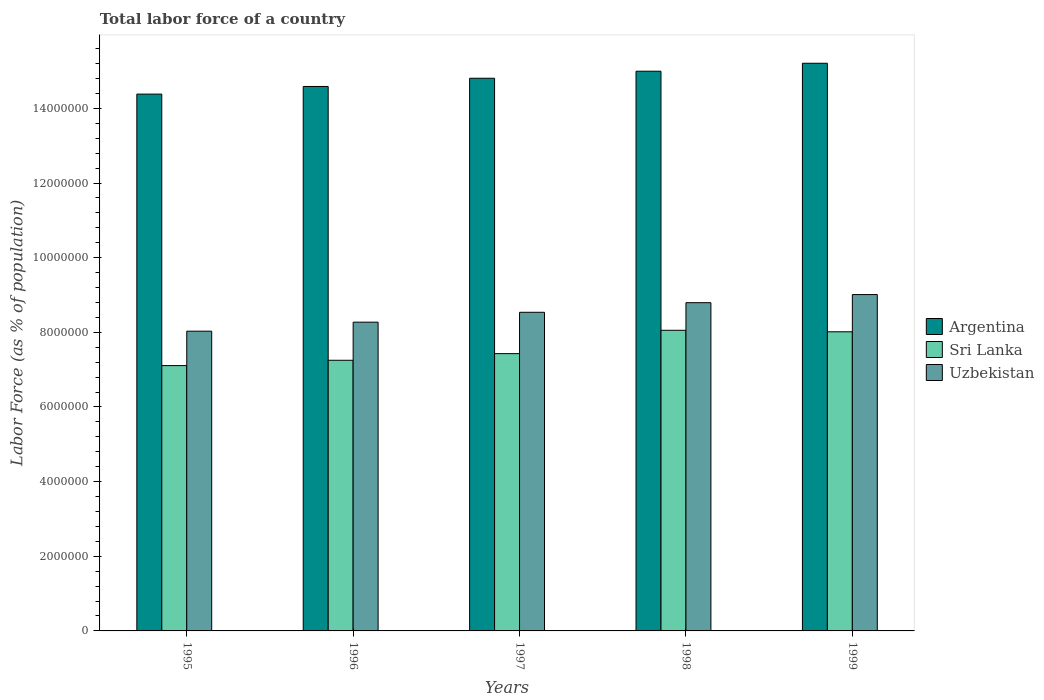Are the number of bars per tick equal to the number of legend labels?
Provide a short and direct response. Yes. Are the number of bars on each tick of the X-axis equal?
Ensure brevity in your answer.  Yes. How many bars are there on the 4th tick from the left?
Give a very brief answer. 3. How many bars are there on the 4th tick from the right?
Offer a very short reply. 3. What is the percentage of labor force in Sri Lanka in 1998?
Your answer should be compact. 8.06e+06. Across all years, what is the maximum percentage of labor force in Uzbekistan?
Give a very brief answer. 9.01e+06. Across all years, what is the minimum percentage of labor force in Argentina?
Your answer should be compact. 1.44e+07. What is the total percentage of labor force in Argentina in the graph?
Your answer should be very brief. 7.40e+07. What is the difference between the percentage of labor force in Argentina in 1996 and that in 1999?
Give a very brief answer. -6.22e+05. What is the difference between the percentage of labor force in Argentina in 1997 and the percentage of labor force in Sri Lanka in 1996?
Your answer should be very brief. 7.56e+06. What is the average percentage of labor force in Argentina per year?
Offer a very short reply. 1.48e+07. In the year 1996, what is the difference between the percentage of labor force in Argentina and percentage of labor force in Sri Lanka?
Ensure brevity in your answer.  7.34e+06. What is the ratio of the percentage of labor force in Uzbekistan in 1997 to that in 1999?
Make the answer very short. 0.95. Is the percentage of labor force in Uzbekistan in 1995 less than that in 1999?
Provide a short and direct response. Yes. What is the difference between the highest and the second highest percentage of labor force in Uzbekistan?
Keep it short and to the point. 2.17e+05. What is the difference between the highest and the lowest percentage of labor force in Argentina?
Ensure brevity in your answer.  8.26e+05. In how many years, is the percentage of labor force in Argentina greater than the average percentage of labor force in Argentina taken over all years?
Provide a succinct answer. 3. What does the 1st bar from the right in 1996 represents?
Keep it short and to the point. Uzbekistan. How many bars are there?
Your answer should be very brief. 15. Are the values on the major ticks of Y-axis written in scientific E-notation?
Keep it short and to the point. No. Does the graph contain grids?
Your response must be concise. No. Where does the legend appear in the graph?
Your answer should be compact. Center right. How many legend labels are there?
Give a very brief answer. 3. How are the legend labels stacked?
Your response must be concise. Vertical. What is the title of the graph?
Your response must be concise. Total labor force of a country. Does "Rwanda" appear as one of the legend labels in the graph?
Make the answer very short. No. What is the label or title of the X-axis?
Offer a very short reply. Years. What is the label or title of the Y-axis?
Ensure brevity in your answer.  Labor Force (as % of population). What is the Labor Force (as % of population) in Argentina in 1995?
Make the answer very short. 1.44e+07. What is the Labor Force (as % of population) in Sri Lanka in 1995?
Offer a very short reply. 7.11e+06. What is the Labor Force (as % of population) of Uzbekistan in 1995?
Your response must be concise. 8.03e+06. What is the Labor Force (as % of population) of Argentina in 1996?
Give a very brief answer. 1.46e+07. What is the Labor Force (as % of population) in Sri Lanka in 1996?
Offer a very short reply. 7.25e+06. What is the Labor Force (as % of population) in Uzbekistan in 1996?
Your answer should be compact. 8.27e+06. What is the Labor Force (as % of population) in Argentina in 1997?
Provide a short and direct response. 1.48e+07. What is the Labor Force (as % of population) in Sri Lanka in 1997?
Provide a short and direct response. 7.43e+06. What is the Labor Force (as % of population) in Uzbekistan in 1997?
Offer a very short reply. 8.54e+06. What is the Labor Force (as % of population) in Argentina in 1998?
Your answer should be very brief. 1.50e+07. What is the Labor Force (as % of population) of Sri Lanka in 1998?
Make the answer very short. 8.06e+06. What is the Labor Force (as % of population) in Uzbekistan in 1998?
Give a very brief answer. 8.80e+06. What is the Labor Force (as % of population) in Argentina in 1999?
Provide a succinct answer. 1.52e+07. What is the Labor Force (as % of population) of Sri Lanka in 1999?
Your answer should be compact. 8.01e+06. What is the Labor Force (as % of population) in Uzbekistan in 1999?
Provide a short and direct response. 9.01e+06. Across all years, what is the maximum Labor Force (as % of population) of Argentina?
Offer a very short reply. 1.52e+07. Across all years, what is the maximum Labor Force (as % of population) of Sri Lanka?
Your answer should be compact. 8.06e+06. Across all years, what is the maximum Labor Force (as % of population) in Uzbekistan?
Give a very brief answer. 9.01e+06. Across all years, what is the minimum Labor Force (as % of population) of Argentina?
Keep it short and to the point. 1.44e+07. Across all years, what is the minimum Labor Force (as % of population) of Sri Lanka?
Offer a very short reply. 7.11e+06. Across all years, what is the minimum Labor Force (as % of population) of Uzbekistan?
Your response must be concise. 8.03e+06. What is the total Labor Force (as % of population) in Argentina in the graph?
Give a very brief answer. 7.40e+07. What is the total Labor Force (as % of population) in Sri Lanka in the graph?
Your answer should be very brief. 3.79e+07. What is the total Labor Force (as % of population) of Uzbekistan in the graph?
Offer a terse response. 4.26e+07. What is the difference between the Labor Force (as % of population) of Argentina in 1995 and that in 1996?
Your answer should be very brief. -2.04e+05. What is the difference between the Labor Force (as % of population) of Sri Lanka in 1995 and that in 1996?
Your response must be concise. -1.43e+05. What is the difference between the Labor Force (as % of population) of Uzbekistan in 1995 and that in 1996?
Make the answer very short. -2.42e+05. What is the difference between the Labor Force (as % of population) of Argentina in 1995 and that in 1997?
Make the answer very short. -4.25e+05. What is the difference between the Labor Force (as % of population) in Sri Lanka in 1995 and that in 1997?
Offer a terse response. -3.21e+05. What is the difference between the Labor Force (as % of population) in Uzbekistan in 1995 and that in 1997?
Your answer should be very brief. -5.06e+05. What is the difference between the Labor Force (as % of population) in Argentina in 1995 and that in 1998?
Give a very brief answer. -6.14e+05. What is the difference between the Labor Force (as % of population) of Sri Lanka in 1995 and that in 1998?
Your response must be concise. -9.46e+05. What is the difference between the Labor Force (as % of population) in Uzbekistan in 1995 and that in 1998?
Make the answer very short. -7.64e+05. What is the difference between the Labor Force (as % of population) of Argentina in 1995 and that in 1999?
Your answer should be compact. -8.26e+05. What is the difference between the Labor Force (as % of population) in Sri Lanka in 1995 and that in 1999?
Offer a very short reply. -9.06e+05. What is the difference between the Labor Force (as % of population) of Uzbekistan in 1995 and that in 1999?
Make the answer very short. -9.81e+05. What is the difference between the Labor Force (as % of population) in Argentina in 1996 and that in 1997?
Your answer should be very brief. -2.21e+05. What is the difference between the Labor Force (as % of population) in Sri Lanka in 1996 and that in 1997?
Your answer should be very brief. -1.78e+05. What is the difference between the Labor Force (as % of population) in Uzbekistan in 1996 and that in 1997?
Your answer should be compact. -2.65e+05. What is the difference between the Labor Force (as % of population) of Argentina in 1996 and that in 1998?
Ensure brevity in your answer.  -4.09e+05. What is the difference between the Labor Force (as % of population) in Sri Lanka in 1996 and that in 1998?
Your answer should be compact. -8.03e+05. What is the difference between the Labor Force (as % of population) of Uzbekistan in 1996 and that in 1998?
Provide a succinct answer. -5.22e+05. What is the difference between the Labor Force (as % of population) of Argentina in 1996 and that in 1999?
Keep it short and to the point. -6.22e+05. What is the difference between the Labor Force (as % of population) of Sri Lanka in 1996 and that in 1999?
Your response must be concise. -7.63e+05. What is the difference between the Labor Force (as % of population) in Uzbekistan in 1996 and that in 1999?
Ensure brevity in your answer.  -7.39e+05. What is the difference between the Labor Force (as % of population) in Argentina in 1997 and that in 1998?
Make the answer very short. -1.88e+05. What is the difference between the Labor Force (as % of population) of Sri Lanka in 1997 and that in 1998?
Provide a short and direct response. -6.25e+05. What is the difference between the Labor Force (as % of population) of Uzbekistan in 1997 and that in 1998?
Make the answer very short. -2.57e+05. What is the difference between the Labor Force (as % of population) of Argentina in 1997 and that in 1999?
Ensure brevity in your answer.  -4.01e+05. What is the difference between the Labor Force (as % of population) in Sri Lanka in 1997 and that in 1999?
Provide a short and direct response. -5.85e+05. What is the difference between the Labor Force (as % of population) in Uzbekistan in 1997 and that in 1999?
Keep it short and to the point. -4.74e+05. What is the difference between the Labor Force (as % of population) of Argentina in 1998 and that in 1999?
Offer a terse response. -2.13e+05. What is the difference between the Labor Force (as % of population) of Sri Lanka in 1998 and that in 1999?
Provide a short and direct response. 4.02e+04. What is the difference between the Labor Force (as % of population) in Uzbekistan in 1998 and that in 1999?
Ensure brevity in your answer.  -2.17e+05. What is the difference between the Labor Force (as % of population) in Argentina in 1995 and the Labor Force (as % of population) in Sri Lanka in 1996?
Offer a terse response. 7.13e+06. What is the difference between the Labor Force (as % of population) in Argentina in 1995 and the Labor Force (as % of population) in Uzbekistan in 1996?
Provide a succinct answer. 6.11e+06. What is the difference between the Labor Force (as % of population) in Sri Lanka in 1995 and the Labor Force (as % of population) in Uzbekistan in 1996?
Your answer should be compact. -1.16e+06. What is the difference between the Labor Force (as % of population) of Argentina in 1995 and the Labor Force (as % of population) of Sri Lanka in 1997?
Offer a very short reply. 6.95e+06. What is the difference between the Labor Force (as % of population) of Argentina in 1995 and the Labor Force (as % of population) of Uzbekistan in 1997?
Ensure brevity in your answer.  5.85e+06. What is the difference between the Labor Force (as % of population) in Sri Lanka in 1995 and the Labor Force (as % of population) in Uzbekistan in 1997?
Ensure brevity in your answer.  -1.43e+06. What is the difference between the Labor Force (as % of population) in Argentina in 1995 and the Labor Force (as % of population) in Sri Lanka in 1998?
Ensure brevity in your answer.  6.33e+06. What is the difference between the Labor Force (as % of population) of Argentina in 1995 and the Labor Force (as % of population) of Uzbekistan in 1998?
Offer a very short reply. 5.59e+06. What is the difference between the Labor Force (as % of population) of Sri Lanka in 1995 and the Labor Force (as % of population) of Uzbekistan in 1998?
Provide a succinct answer. -1.69e+06. What is the difference between the Labor Force (as % of population) in Argentina in 1995 and the Labor Force (as % of population) in Sri Lanka in 1999?
Give a very brief answer. 6.37e+06. What is the difference between the Labor Force (as % of population) in Argentina in 1995 and the Labor Force (as % of population) in Uzbekistan in 1999?
Provide a short and direct response. 5.37e+06. What is the difference between the Labor Force (as % of population) of Sri Lanka in 1995 and the Labor Force (as % of population) of Uzbekistan in 1999?
Provide a succinct answer. -1.90e+06. What is the difference between the Labor Force (as % of population) in Argentina in 1996 and the Labor Force (as % of population) in Sri Lanka in 1997?
Provide a succinct answer. 7.16e+06. What is the difference between the Labor Force (as % of population) of Argentina in 1996 and the Labor Force (as % of population) of Uzbekistan in 1997?
Make the answer very short. 6.05e+06. What is the difference between the Labor Force (as % of population) of Sri Lanka in 1996 and the Labor Force (as % of population) of Uzbekistan in 1997?
Offer a terse response. -1.29e+06. What is the difference between the Labor Force (as % of population) in Argentina in 1996 and the Labor Force (as % of population) in Sri Lanka in 1998?
Keep it short and to the point. 6.53e+06. What is the difference between the Labor Force (as % of population) of Argentina in 1996 and the Labor Force (as % of population) of Uzbekistan in 1998?
Offer a very short reply. 5.79e+06. What is the difference between the Labor Force (as % of population) of Sri Lanka in 1996 and the Labor Force (as % of population) of Uzbekistan in 1998?
Make the answer very short. -1.54e+06. What is the difference between the Labor Force (as % of population) in Argentina in 1996 and the Labor Force (as % of population) in Sri Lanka in 1999?
Give a very brief answer. 6.57e+06. What is the difference between the Labor Force (as % of population) in Argentina in 1996 and the Labor Force (as % of population) in Uzbekistan in 1999?
Your response must be concise. 5.58e+06. What is the difference between the Labor Force (as % of population) of Sri Lanka in 1996 and the Labor Force (as % of population) of Uzbekistan in 1999?
Keep it short and to the point. -1.76e+06. What is the difference between the Labor Force (as % of population) of Argentina in 1997 and the Labor Force (as % of population) of Sri Lanka in 1998?
Give a very brief answer. 6.75e+06. What is the difference between the Labor Force (as % of population) of Argentina in 1997 and the Labor Force (as % of population) of Uzbekistan in 1998?
Your response must be concise. 6.01e+06. What is the difference between the Labor Force (as % of population) of Sri Lanka in 1997 and the Labor Force (as % of population) of Uzbekistan in 1998?
Your answer should be compact. -1.37e+06. What is the difference between the Labor Force (as % of population) of Argentina in 1997 and the Labor Force (as % of population) of Sri Lanka in 1999?
Your answer should be compact. 6.79e+06. What is the difference between the Labor Force (as % of population) of Argentina in 1997 and the Labor Force (as % of population) of Uzbekistan in 1999?
Your answer should be compact. 5.80e+06. What is the difference between the Labor Force (as % of population) in Sri Lanka in 1997 and the Labor Force (as % of population) in Uzbekistan in 1999?
Provide a succinct answer. -1.58e+06. What is the difference between the Labor Force (as % of population) in Argentina in 1998 and the Labor Force (as % of population) in Sri Lanka in 1999?
Provide a succinct answer. 6.98e+06. What is the difference between the Labor Force (as % of population) of Argentina in 1998 and the Labor Force (as % of population) of Uzbekistan in 1999?
Your answer should be compact. 5.99e+06. What is the difference between the Labor Force (as % of population) of Sri Lanka in 1998 and the Labor Force (as % of population) of Uzbekistan in 1999?
Offer a terse response. -9.57e+05. What is the average Labor Force (as % of population) in Argentina per year?
Offer a terse response. 1.48e+07. What is the average Labor Force (as % of population) of Sri Lanka per year?
Provide a succinct answer. 7.57e+06. What is the average Labor Force (as % of population) of Uzbekistan per year?
Your answer should be compact. 8.53e+06. In the year 1995, what is the difference between the Labor Force (as % of population) of Argentina and Labor Force (as % of population) of Sri Lanka?
Offer a terse response. 7.27e+06. In the year 1995, what is the difference between the Labor Force (as % of population) of Argentina and Labor Force (as % of population) of Uzbekistan?
Your answer should be compact. 6.35e+06. In the year 1995, what is the difference between the Labor Force (as % of population) in Sri Lanka and Labor Force (as % of population) in Uzbekistan?
Provide a short and direct response. -9.23e+05. In the year 1996, what is the difference between the Labor Force (as % of population) in Argentina and Labor Force (as % of population) in Sri Lanka?
Give a very brief answer. 7.34e+06. In the year 1996, what is the difference between the Labor Force (as % of population) in Argentina and Labor Force (as % of population) in Uzbekistan?
Your response must be concise. 6.31e+06. In the year 1996, what is the difference between the Labor Force (as % of population) of Sri Lanka and Labor Force (as % of population) of Uzbekistan?
Your answer should be compact. -1.02e+06. In the year 1997, what is the difference between the Labor Force (as % of population) in Argentina and Labor Force (as % of population) in Sri Lanka?
Provide a succinct answer. 7.38e+06. In the year 1997, what is the difference between the Labor Force (as % of population) of Argentina and Labor Force (as % of population) of Uzbekistan?
Provide a short and direct response. 6.27e+06. In the year 1997, what is the difference between the Labor Force (as % of population) in Sri Lanka and Labor Force (as % of population) in Uzbekistan?
Ensure brevity in your answer.  -1.11e+06. In the year 1998, what is the difference between the Labor Force (as % of population) of Argentina and Labor Force (as % of population) of Sri Lanka?
Your answer should be very brief. 6.94e+06. In the year 1998, what is the difference between the Labor Force (as % of population) in Argentina and Labor Force (as % of population) in Uzbekistan?
Your answer should be very brief. 6.20e+06. In the year 1998, what is the difference between the Labor Force (as % of population) of Sri Lanka and Labor Force (as % of population) of Uzbekistan?
Give a very brief answer. -7.40e+05. In the year 1999, what is the difference between the Labor Force (as % of population) of Argentina and Labor Force (as % of population) of Sri Lanka?
Provide a succinct answer. 7.20e+06. In the year 1999, what is the difference between the Labor Force (as % of population) of Argentina and Labor Force (as % of population) of Uzbekistan?
Keep it short and to the point. 6.20e+06. In the year 1999, what is the difference between the Labor Force (as % of population) in Sri Lanka and Labor Force (as % of population) in Uzbekistan?
Your answer should be compact. -9.97e+05. What is the ratio of the Labor Force (as % of population) of Argentina in 1995 to that in 1996?
Ensure brevity in your answer.  0.99. What is the ratio of the Labor Force (as % of population) in Sri Lanka in 1995 to that in 1996?
Ensure brevity in your answer.  0.98. What is the ratio of the Labor Force (as % of population) in Uzbekistan in 1995 to that in 1996?
Your response must be concise. 0.97. What is the ratio of the Labor Force (as % of population) of Argentina in 1995 to that in 1997?
Your answer should be compact. 0.97. What is the ratio of the Labor Force (as % of population) in Sri Lanka in 1995 to that in 1997?
Your response must be concise. 0.96. What is the ratio of the Labor Force (as % of population) of Uzbekistan in 1995 to that in 1997?
Your answer should be very brief. 0.94. What is the ratio of the Labor Force (as % of population) in Argentina in 1995 to that in 1998?
Offer a very short reply. 0.96. What is the ratio of the Labor Force (as % of population) of Sri Lanka in 1995 to that in 1998?
Your response must be concise. 0.88. What is the ratio of the Labor Force (as % of population) in Uzbekistan in 1995 to that in 1998?
Give a very brief answer. 0.91. What is the ratio of the Labor Force (as % of population) in Argentina in 1995 to that in 1999?
Provide a short and direct response. 0.95. What is the ratio of the Labor Force (as % of population) of Sri Lanka in 1995 to that in 1999?
Offer a very short reply. 0.89. What is the ratio of the Labor Force (as % of population) in Uzbekistan in 1995 to that in 1999?
Offer a very short reply. 0.89. What is the ratio of the Labor Force (as % of population) in Argentina in 1996 to that in 1997?
Make the answer very short. 0.99. What is the ratio of the Labor Force (as % of population) of Sri Lanka in 1996 to that in 1997?
Keep it short and to the point. 0.98. What is the ratio of the Labor Force (as % of population) of Uzbekistan in 1996 to that in 1997?
Provide a succinct answer. 0.97. What is the ratio of the Labor Force (as % of population) of Argentina in 1996 to that in 1998?
Ensure brevity in your answer.  0.97. What is the ratio of the Labor Force (as % of population) in Sri Lanka in 1996 to that in 1998?
Your response must be concise. 0.9. What is the ratio of the Labor Force (as % of population) of Uzbekistan in 1996 to that in 1998?
Your answer should be compact. 0.94. What is the ratio of the Labor Force (as % of population) of Argentina in 1996 to that in 1999?
Your answer should be compact. 0.96. What is the ratio of the Labor Force (as % of population) in Sri Lanka in 1996 to that in 1999?
Make the answer very short. 0.9. What is the ratio of the Labor Force (as % of population) of Uzbekistan in 1996 to that in 1999?
Your answer should be compact. 0.92. What is the ratio of the Labor Force (as % of population) in Argentina in 1997 to that in 1998?
Keep it short and to the point. 0.99. What is the ratio of the Labor Force (as % of population) of Sri Lanka in 1997 to that in 1998?
Keep it short and to the point. 0.92. What is the ratio of the Labor Force (as % of population) of Uzbekistan in 1997 to that in 1998?
Provide a short and direct response. 0.97. What is the ratio of the Labor Force (as % of population) in Argentina in 1997 to that in 1999?
Provide a succinct answer. 0.97. What is the ratio of the Labor Force (as % of population) in Sri Lanka in 1997 to that in 1999?
Provide a succinct answer. 0.93. What is the ratio of the Labor Force (as % of population) of Uzbekistan in 1997 to that in 1999?
Make the answer very short. 0.95. What is the ratio of the Labor Force (as % of population) of Uzbekistan in 1998 to that in 1999?
Your response must be concise. 0.98. What is the difference between the highest and the second highest Labor Force (as % of population) of Argentina?
Keep it short and to the point. 2.13e+05. What is the difference between the highest and the second highest Labor Force (as % of population) in Sri Lanka?
Offer a very short reply. 4.02e+04. What is the difference between the highest and the second highest Labor Force (as % of population) of Uzbekistan?
Keep it short and to the point. 2.17e+05. What is the difference between the highest and the lowest Labor Force (as % of population) in Argentina?
Offer a very short reply. 8.26e+05. What is the difference between the highest and the lowest Labor Force (as % of population) of Sri Lanka?
Provide a succinct answer. 9.46e+05. What is the difference between the highest and the lowest Labor Force (as % of population) of Uzbekistan?
Your response must be concise. 9.81e+05. 